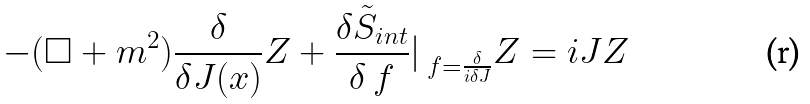<formula> <loc_0><loc_0><loc_500><loc_500>- ( \square + m ^ { 2 } ) \frac { \delta } { \delta J ( x ) } Z + \frac { \delta \tilde { S } _ { i n t } } { \delta \ f } | _ { \ f = \frac { \delta } { i \delta J } } Z = i J Z</formula> 